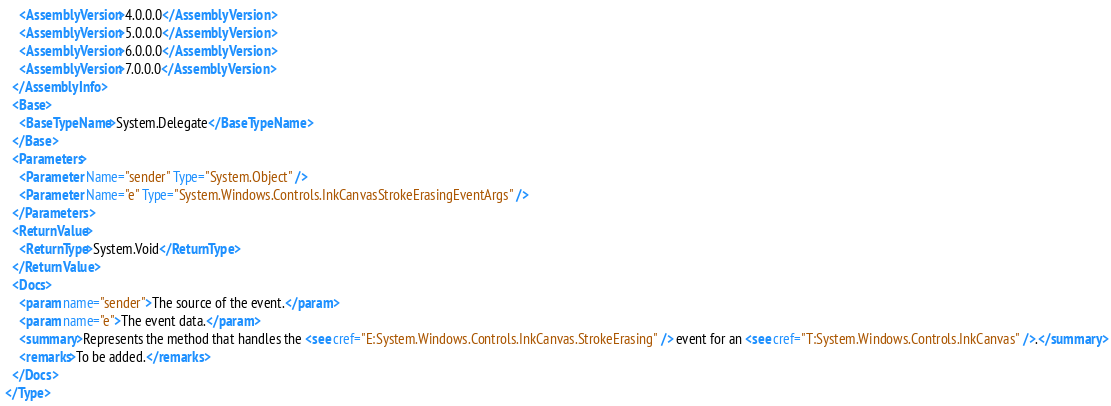<code> <loc_0><loc_0><loc_500><loc_500><_XML_>    <AssemblyVersion>4.0.0.0</AssemblyVersion>
    <AssemblyVersion>5.0.0.0</AssemblyVersion>
    <AssemblyVersion>6.0.0.0</AssemblyVersion>
    <AssemblyVersion>7.0.0.0</AssemblyVersion>
  </AssemblyInfo>
  <Base>
    <BaseTypeName>System.Delegate</BaseTypeName>
  </Base>
  <Parameters>
    <Parameter Name="sender" Type="System.Object" />
    <Parameter Name="e" Type="System.Windows.Controls.InkCanvasStrokeErasingEventArgs" />
  </Parameters>
  <ReturnValue>
    <ReturnType>System.Void</ReturnType>
  </ReturnValue>
  <Docs>
    <param name="sender">The source of the event.</param>
    <param name="e">The event data.</param>
    <summary>Represents the method that handles the <see cref="E:System.Windows.Controls.InkCanvas.StrokeErasing" /> event for an <see cref="T:System.Windows.Controls.InkCanvas" />.</summary>
    <remarks>To be added.</remarks>
  </Docs>
</Type>
</code> 